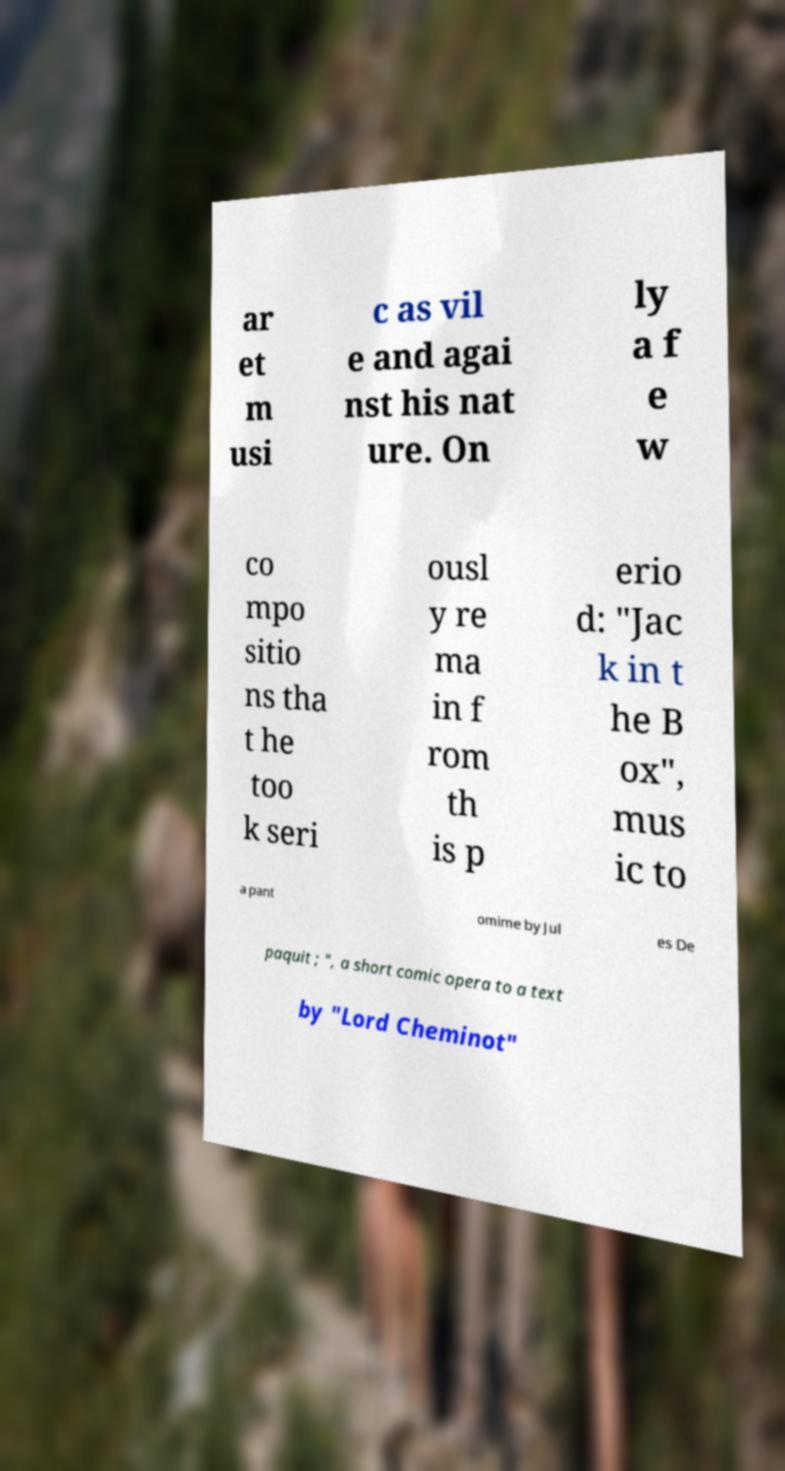Please read and relay the text visible in this image. What does it say? ar et m usi c as vil e and agai nst his nat ure. On ly a f e w co mpo sitio ns tha t he too k seri ousl y re ma in f rom th is p erio d: "Jac k in t he B ox", mus ic to a pant omime by Jul es De paquit ; ", a short comic opera to a text by "Lord Cheminot" 